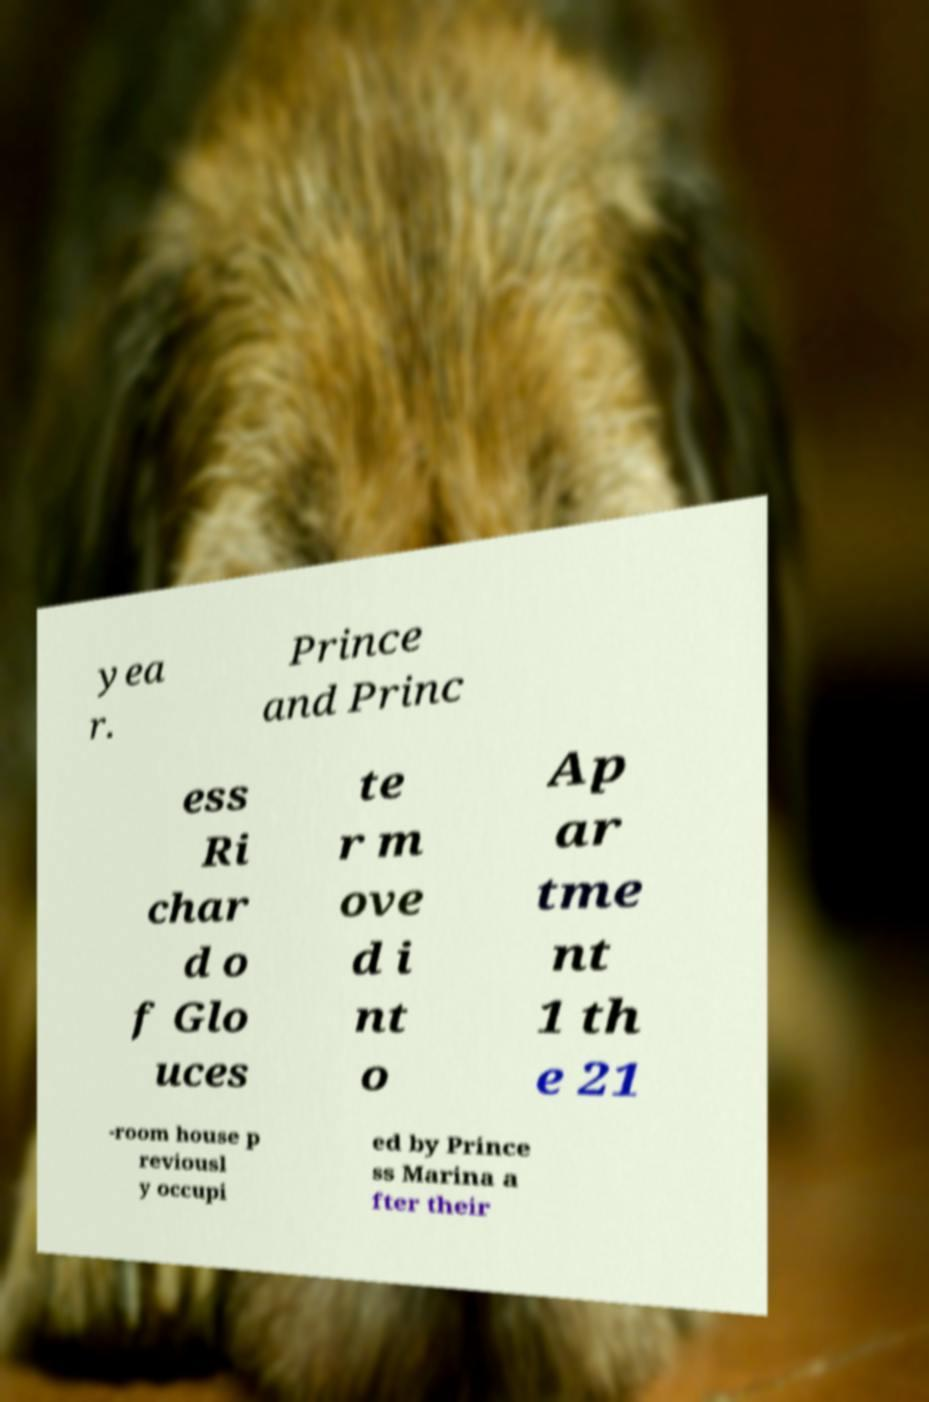For documentation purposes, I need the text within this image transcribed. Could you provide that? yea r. Prince and Princ ess Ri char d o f Glo uces te r m ove d i nt o Ap ar tme nt 1 th e 21 -room house p reviousl y occupi ed by Prince ss Marina a fter their 